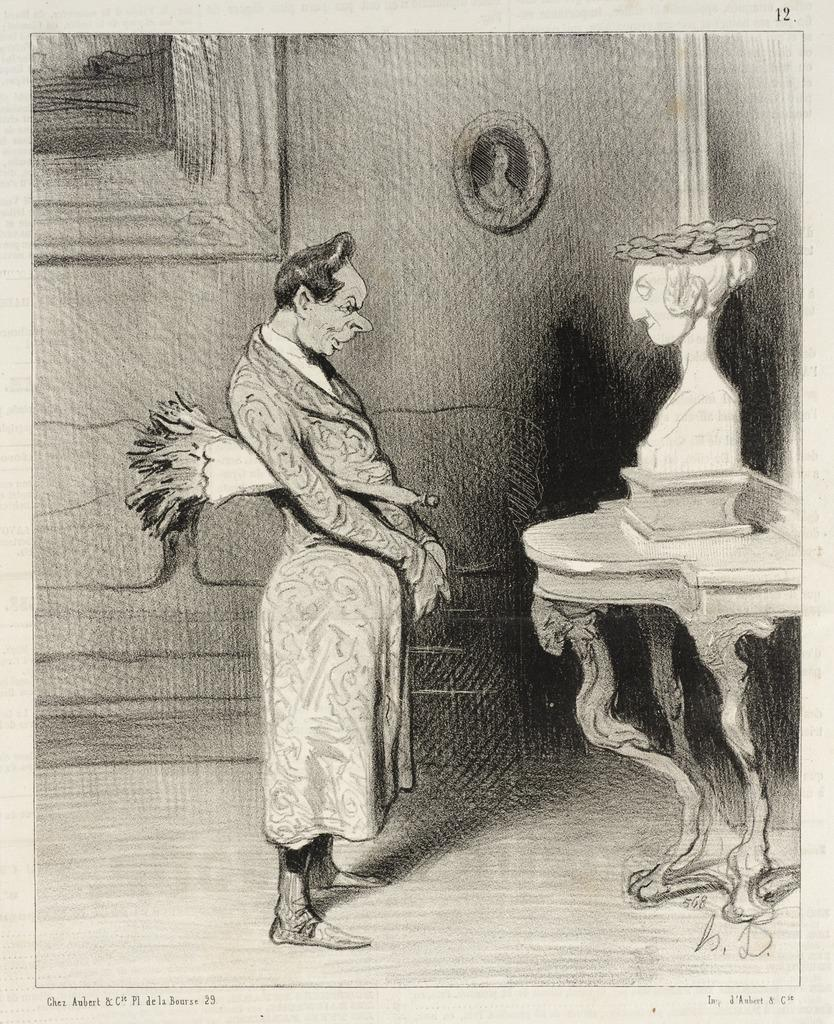What is the main subject of the image? There is a drawing in the image. Are there any other objects related to visual art in the image? Yes, there are two photo frames in the image. Can you describe the person in the image? There is a person in the image, but no specific details about their appearance or actions are provided. How many cubs can be seen playing with the birds in the image? There are no cubs or birds present in the image; it features a drawing and photo frames. 